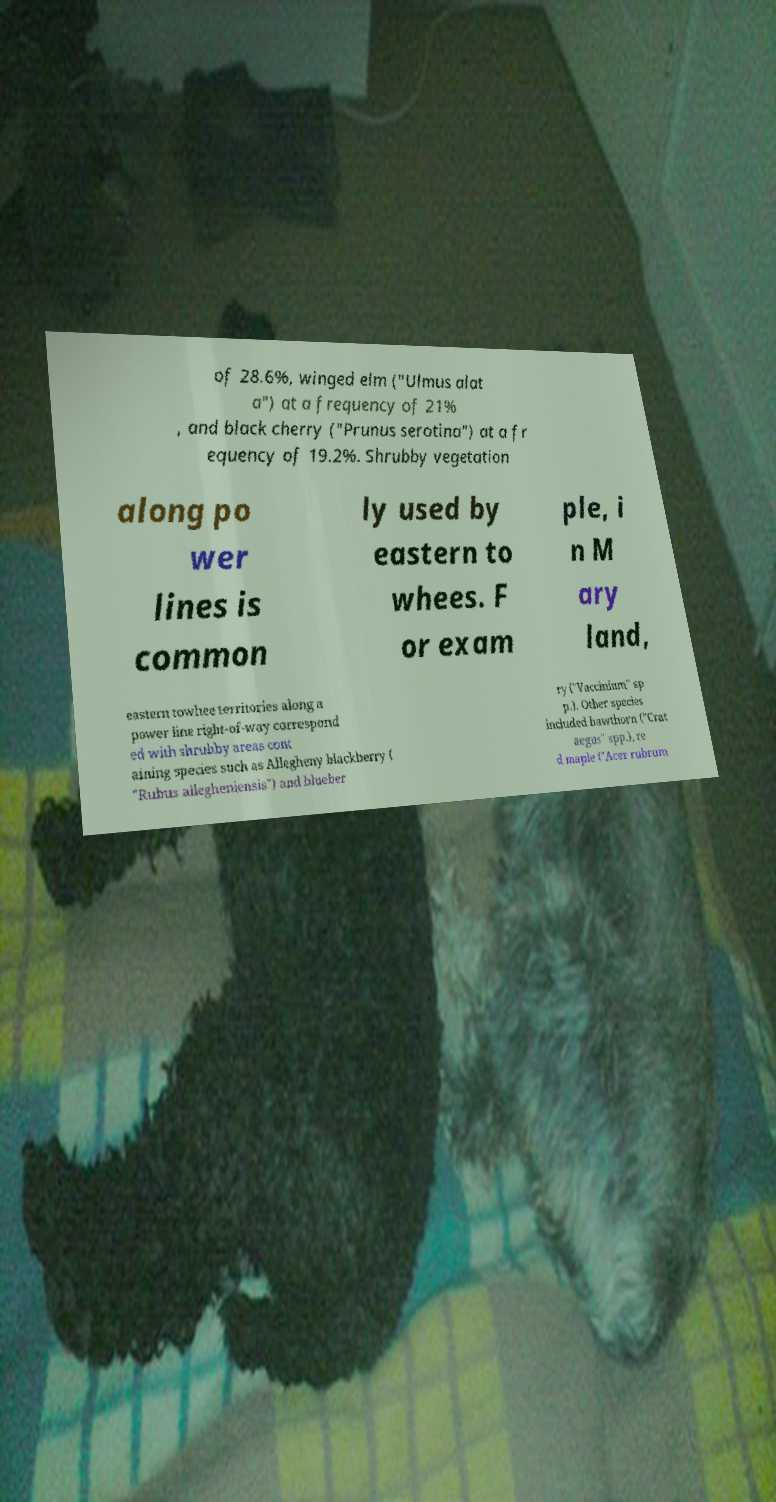Can you read and provide the text displayed in the image?This photo seems to have some interesting text. Can you extract and type it out for me? of 28.6%, winged elm ("Ulmus alat a") at a frequency of 21% , and black cherry ("Prunus serotina") at a fr equency of 19.2%. Shrubby vegetation along po wer lines is common ly used by eastern to whees. F or exam ple, i n M ary land, eastern towhee territories along a power line right-of-way correspond ed with shrubby areas cont aining species such as Allegheny blackberry ( "Rubus allegheniensis") and blueber ry ("Vaccinium" sp p.). Other species included hawthorn ("Crat aegus" spp.), re d maple ("Acer rubrum 